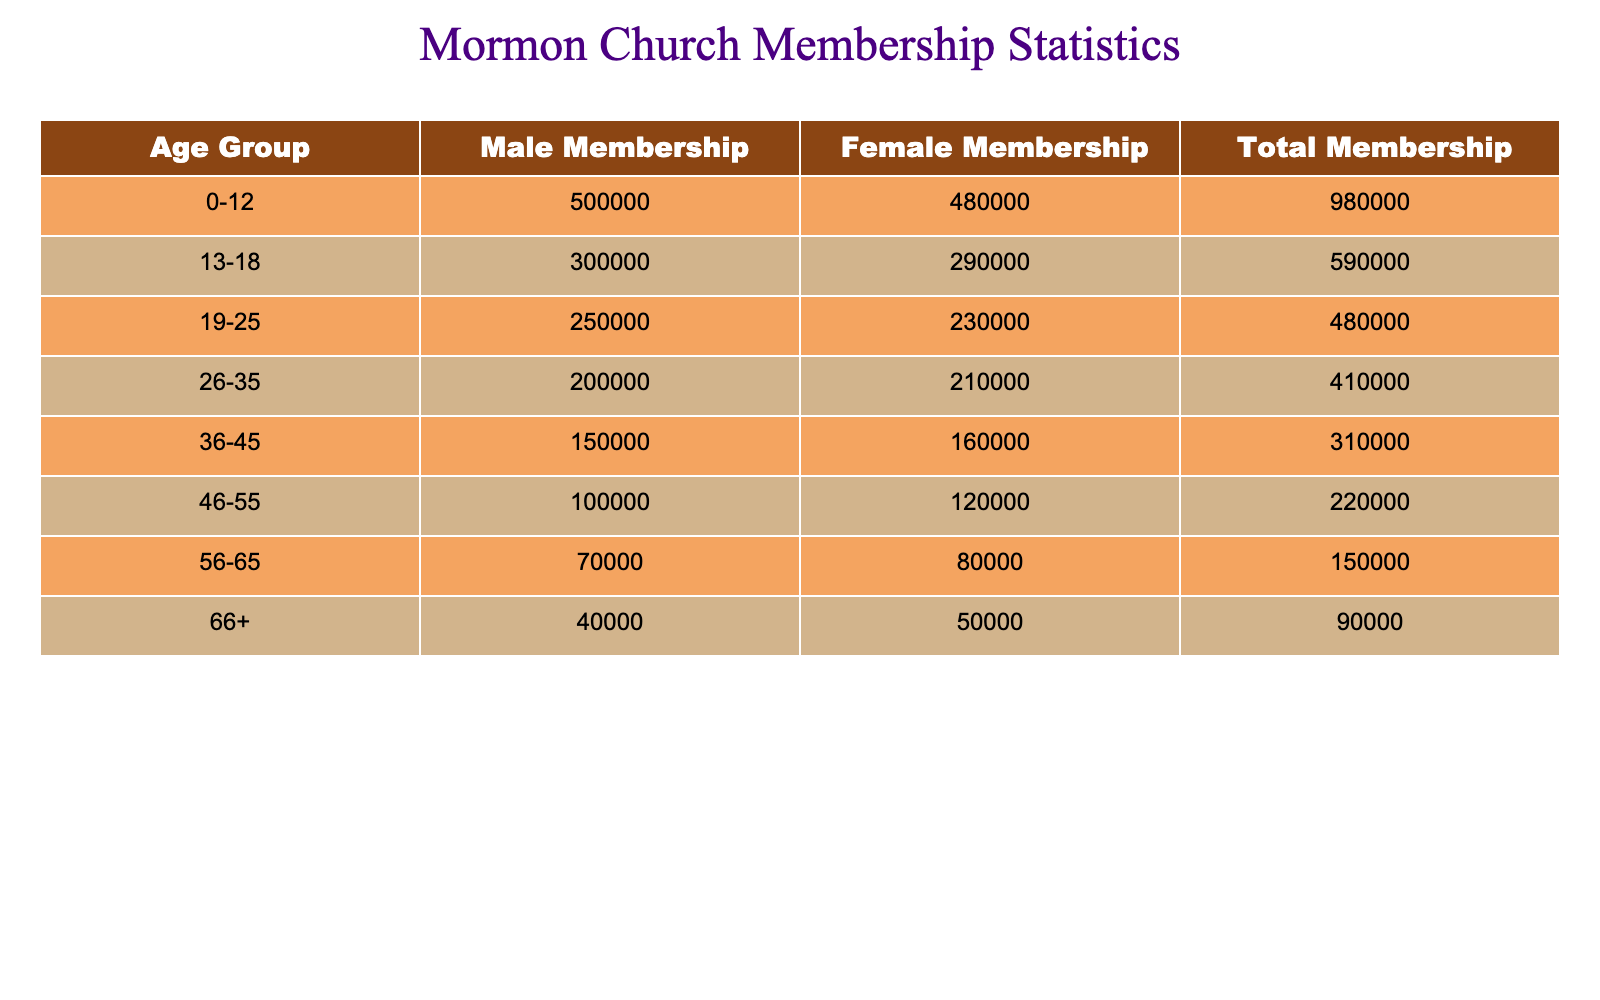What is the total membership of the 0-12 age group? The table lists the total membership of the 0-12 age group as 980,000.
Answer: 980000 How many male members are there in the 19-25 age group? According to the table, the male membership in the 19-25 age group is 250,000.
Answer: 250000 Which age group has the highest total membership? By reviewing the total membership for each age group, the 0-12 age group has the highest total membership of 980,000.
Answer: 0-12 What is the difference in male membership between the 36-45 and 46-55 age groups? The male membership in the 36-45 age group is 150,000, and in the 46-55 age group, it is 100,000. The difference is 150,000 - 100,000 = 50,000.
Answer: 50000 What is the total female membership across all age groups? To find the total female membership, sum the female members in each age group: 480,000 + 290,000 + 230,000 + 210,000 + 160,000 + 120,000 + 80,000 + 50,000 = 1,620,000.
Answer: 1620000 Is there a higher total membership in the 66+ age group compared to the 26-35 age group? The total membership for the 66+ age group is 90,000, while for the 26-35 age group, it is 410,000. Since 90,000 is less than 410,000, the statement is false.
Answer: No What is the average male membership across all age groups? The male memberships for all age groups are: 500,000, 300,000, 250,000, 200,000, 150,000, 100,000, 70,000, and 40,000. Summing these gives 1,610,000; dividing by 8 (the number of age groups) gives an average of 201,250.
Answer: 201250 Which gender has a higher membership in the 26-35 age group? Reviewing the table, female membership in the 26-35 age group is 210,000 while male membership is 200,000. Since 210,000 is greater than 200,000, females have a higher membership in this group.
Answer: Female What percentage of the total membership is made up by the male members in the 56-65 age group? The total membership for the 56-65 age group is 150,000, and the male membership is 70,000. The percentage is calculated by (70,000 / 150,000) * 100 = 46.67%.
Answer: 46.67% What is the total membership of all age groups combined? By summing the total memberships from all age groups: 980,000 + 590,000 + 480,000 + 410,000 + 310,000 + 220,000 + 150,000 + 90,000 = 3,430,000.
Answer: 3430000 